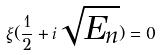Convert formula to latex. <formula><loc_0><loc_0><loc_500><loc_500>\xi ( \frac { 1 } { 2 } + i \sqrt { E _ { n } } ) = 0</formula> 